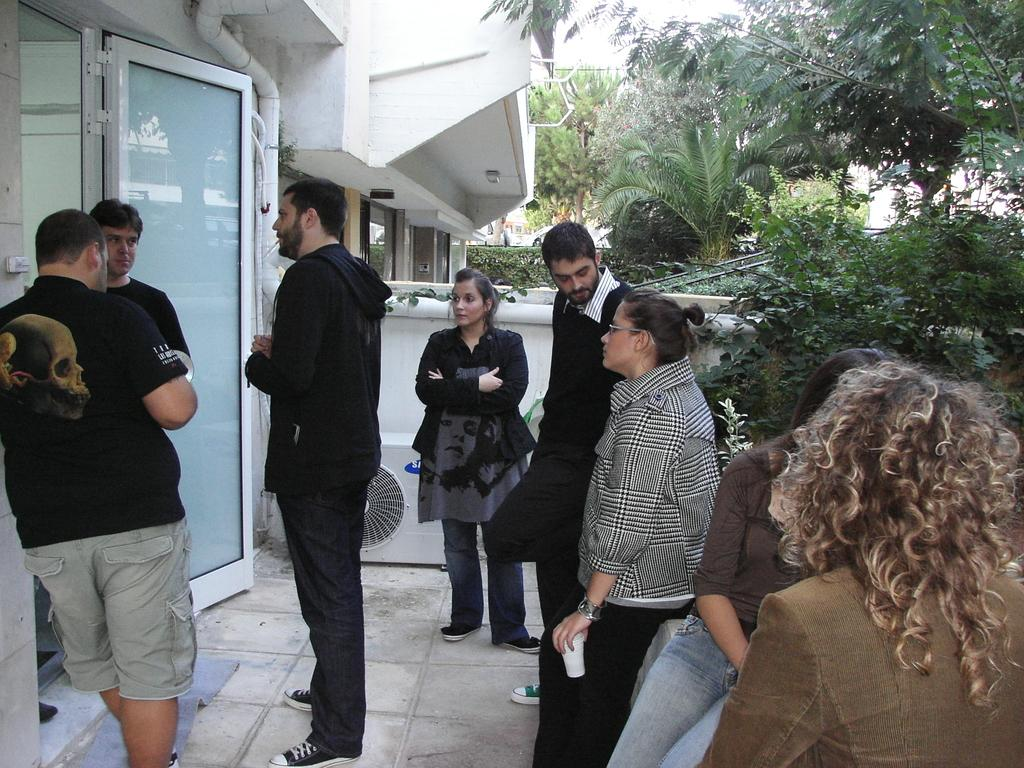What are the people in the image doing? There are many people standing and talking in the image. Where is the door located in the image? The door is to the left in the image. What can be seen in the background of the image? There is a building, trees, and plants visible in the background of the image. How many plates are being used by the people in the image? There is no mention of plates in the image; people are standing and talking. Can you see any ants crawling on the people in the image? There are no ants visible in the image; it features people standing and talking. 